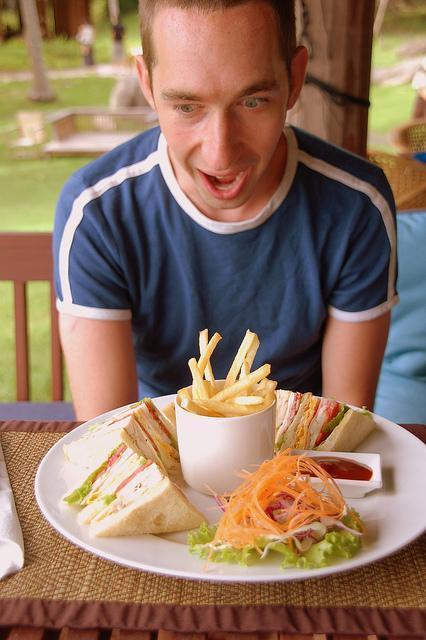How many hot dogs are on his plate?
Give a very brief answer. 0. How many sandwiches are there?
Give a very brief answer. 2. 